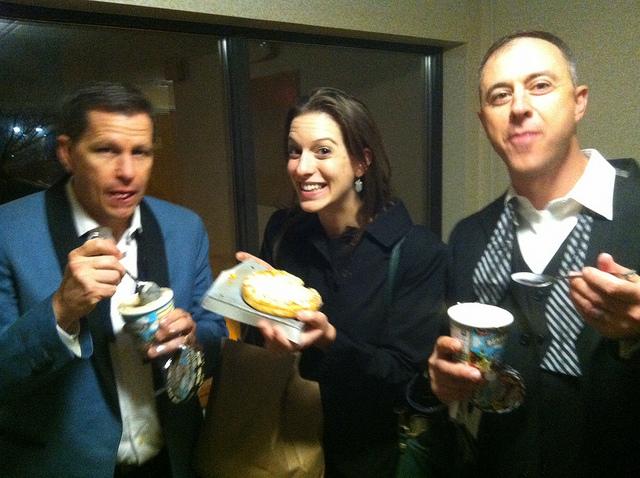How many screws do you see?
Answer briefly. 0. How many people are showing their teeth?
Quick response, please. 1. What are these people holding?
Be succinct. Food. 